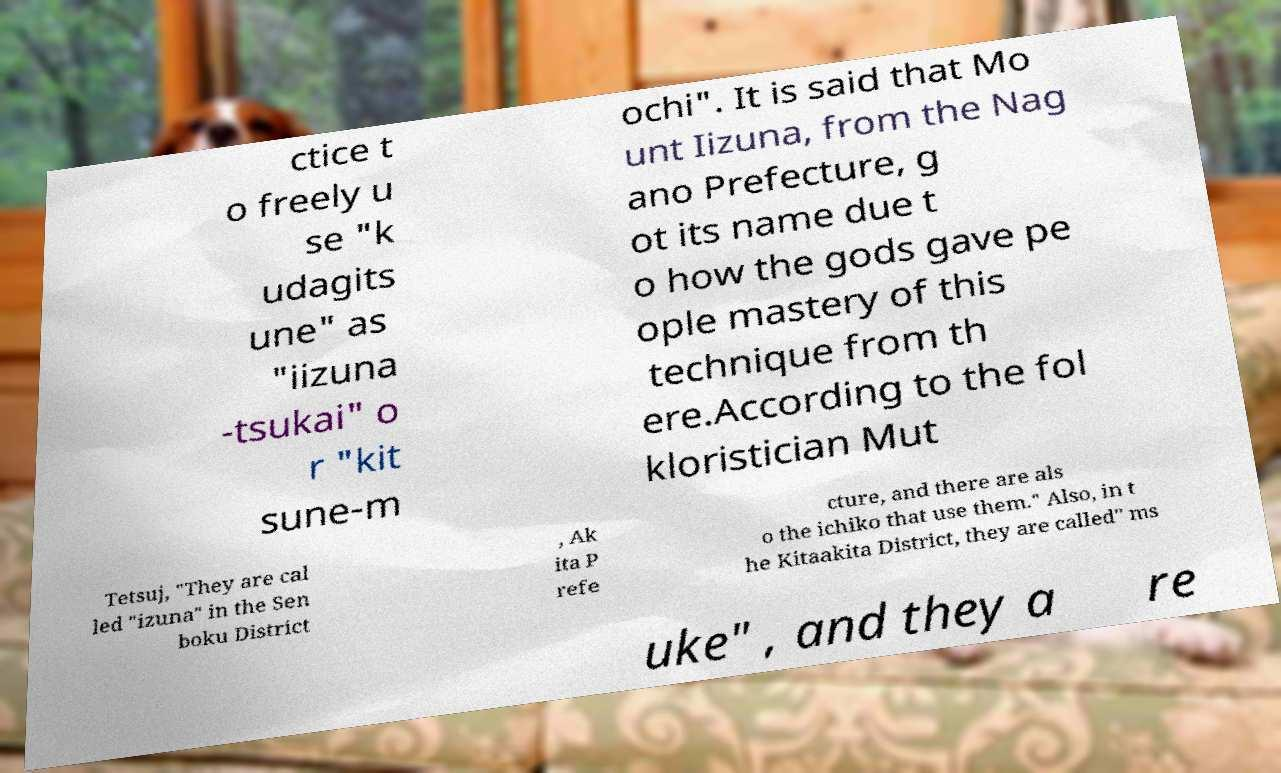There's text embedded in this image that I need extracted. Can you transcribe it verbatim? ctice t o freely u se "k udagits une" as "iizuna -tsukai" o r "kit sune-m ochi". It is said that Mo unt Iizuna, from the Nag ano Prefecture, g ot its name due t o how the gods gave pe ople mastery of this technique from th ere.According to the fol kloristician Mut Tetsuj, "They are cal led "izuna" in the Sen boku District , Ak ita P refe cture, and there are als o the ichiko that use them." Also, in t he Kitaakita District, they are called" ms uke" , and they a re 